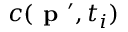<formula> <loc_0><loc_0><loc_500><loc_500>c ( p ^ { \prime } , t _ { i } )</formula> 